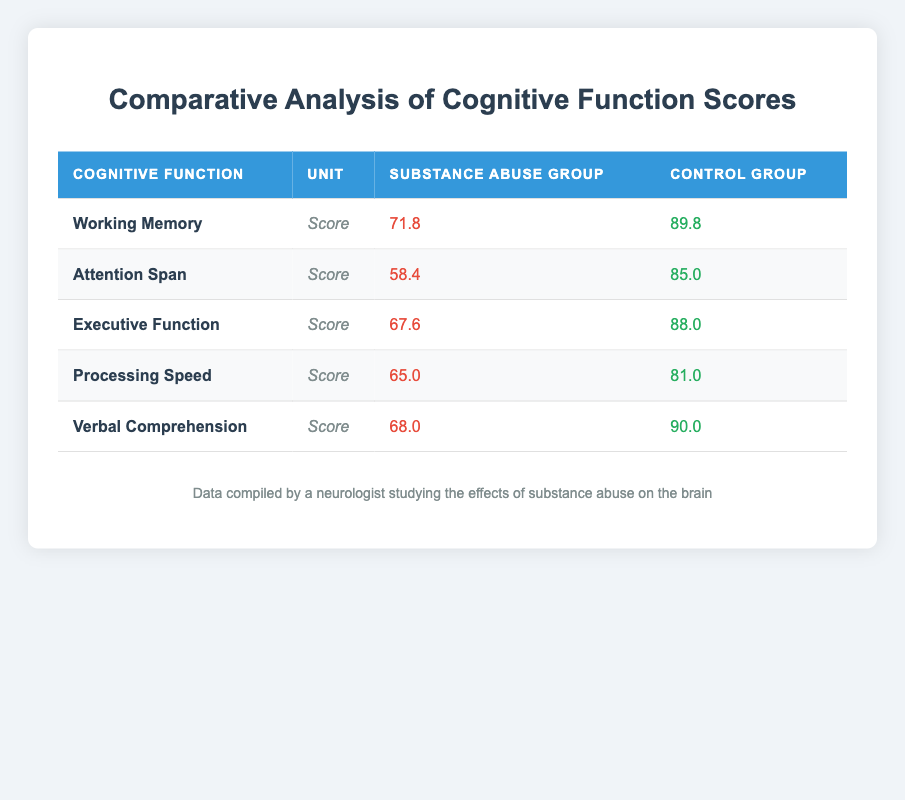What is the average score for working memory in individuals with a history of substance abuse? The average score for working memory in individuals with a history of substance abuse is given directly in the table as 71.8.
Answer: 71.8 What is the average score for verbal comprehension in the control group? The average score for verbal comprehension in the control group is found in the table as 90.0.
Answer: 90.0 Is the average attention span score higher in the control group than in the group with a history of substance abuse? Looking at the table, the average attention span score for the control group is 85.0, while for the substance abuse group, it is 58.4. Since 85.0 > 58.4, the statement is true.
Answer: Yes What is the difference in the average executive function scores between the two groups? The average executive function score for the substance abuse group is 67.6 and for the control group is 88.0. To find the difference, subtract the abuse group score from the control group score: 88.0 - 67.6 = 20.4.
Answer: 20.4 Which cognitive function shows the largest difference in average scores between the two groups? To determine which cognitive function shows the largest difference, calculate the absolute differences from the averages: Working Memory (89.8 - 71.8 = 18.0), Attention Span (85.0 - 58.4 = 26.6), Executive Function (88.0 - 67.6 = 20.4), Processing Speed (81.0 - 65.0 = 16.0), and Verbal Comprehension (90.0 - 68.0 = 22.0). The largest difference is 26.6 for Attention Span.
Answer: Attention Span Do individuals with a history of substance abuse have a higher processing speed average than the control group? The average processing speed for the substance abuse group is 65.0, and for the control group, it is 81.0. Since 65.0 is not greater than 81.0, the answer is no.
Answer: No 